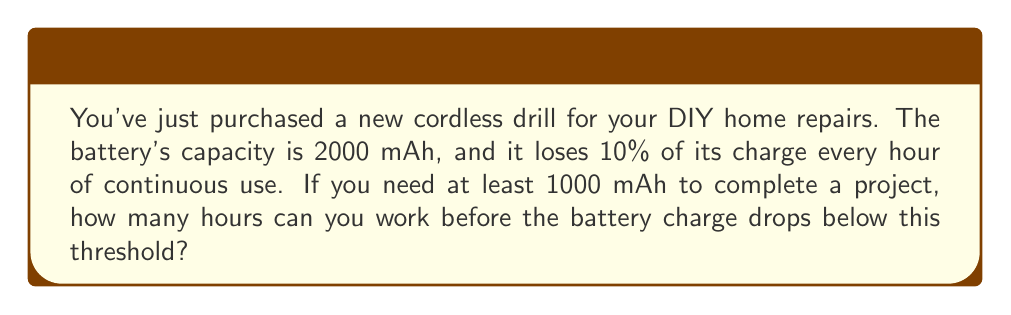Can you answer this question? Let's approach this step-by-step using exponential decay:

1) The exponential decay formula is:
   $A(t) = A_0 \cdot (1-r)^t$
   Where:
   $A(t)$ is the amount remaining after time $t$
   $A_0$ is the initial amount
   $r$ is the decay rate per unit time
   $t$ is the time

2) In this case:
   $A_0 = 2000$ mAh
   $r = 0.10$ (10% decay per hour)
   We need to find $t$ when $A(t) = 1000$ mAh

3) Plugging into the formula:
   $1000 = 2000 \cdot (1-0.10)^t$

4) Simplify:
   $1000 = 2000 \cdot (0.9)^t$

5) Divide both sides by 2000:
   $0.5 = (0.9)^t$

6) Take the natural log of both sides:
   $\ln(0.5) = \ln((0.9)^t)$

7) Use the logarithm property $\ln(a^b) = b\ln(a)$:
   $\ln(0.5) = t \cdot \ln(0.9)$

8) Solve for $t$:
   $t = \frac{\ln(0.5)}{\ln(0.9)} \approx 6.58$ hours

Therefore, you can work for approximately 6.58 hours before the battery charge drops below 1000 mAh.
Answer: 6.58 hours 